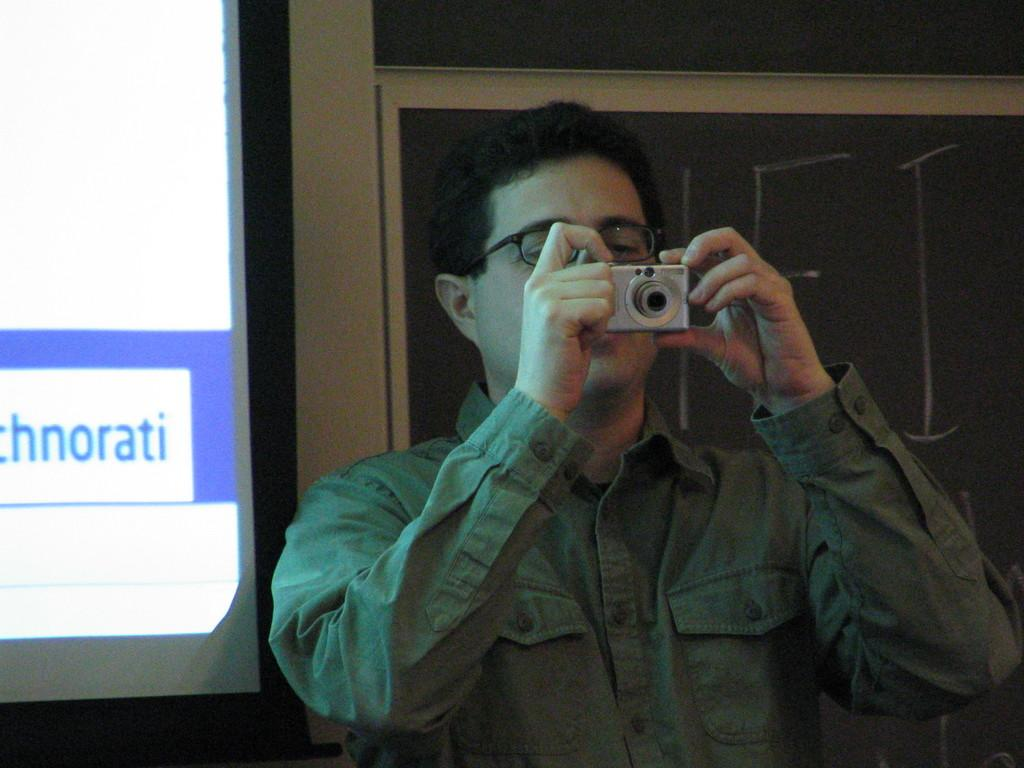What is present in the image? There is a man in the image. What is the man holding in the image? The man is holding a camera. How many frogs can be seen in the image? There are no frogs present in the image. Can you provide an example of a different object the man could be holding in the image? It is impossible to provide an example of a different object the man could be holding in the image, as we can only describe the objects that are actually present in the image. 